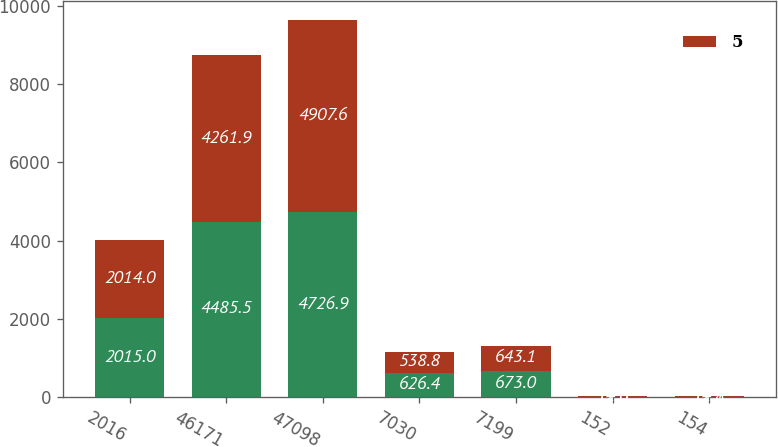Convert chart to OTSL. <chart><loc_0><loc_0><loc_500><loc_500><stacked_bar_chart><ecel><fcel>2016<fcel>46171<fcel>47098<fcel>7030<fcel>7199<fcel>152<fcel>154<nl><fcel>nan<fcel>2015<fcel>4485.5<fcel>4726.9<fcel>626.4<fcel>673<fcel>14<fcel>14.1<nl><fcel>5<fcel>2014<fcel>4261.9<fcel>4907.6<fcel>538.8<fcel>643.1<fcel>12.6<fcel>12.8<nl></chart> 